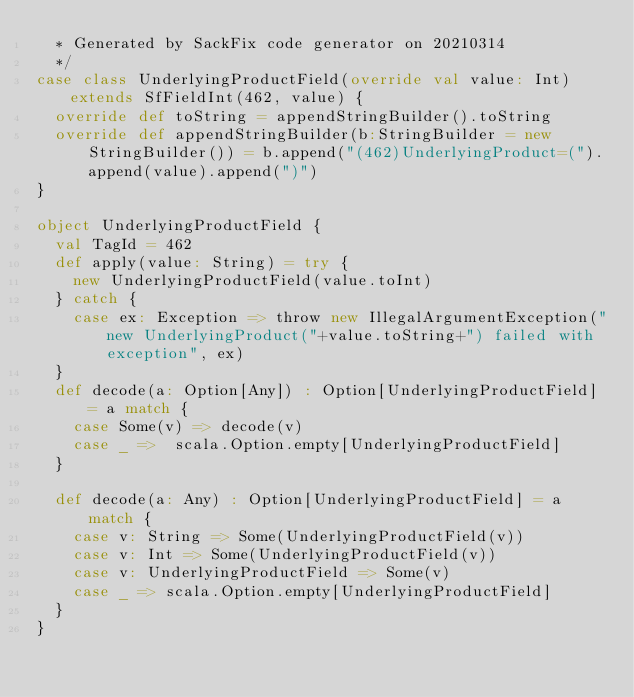<code> <loc_0><loc_0><loc_500><loc_500><_Scala_>  * Generated by SackFix code generator on 20210314
  */
case class UnderlyingProductField(override val value: Int) extends SfFieldInt(462, value) {
  override def toString = appendStringBuilder().toString
  override def appendStringBuilder(b:StringBuilder = new StringBuilder()) = b.append("(462)UnderlyingProduct=(").append(value).append(")")
}

object UnderlyingProductField {
  val TagId = 462  
  def apply(value: String) = try {
    new UnderlyingProductField(value.toInt)
  } catch {
    case ex: Exception => throw new IllegalArgumentException("new UnderlyingProduct("+value.toString+") failed with exception", ex)
  } 
  def decode(a: Option[Any]) : Option[UnderlyingProductField] = a match {
    case Some(v) => decode(v)
    case _ =>  scala.Option.empty[UnderlyingProductField]
  }

  def decode(a: Any) : Option[UnderlyingProductField] = a match {
    case v: String => Some(UnderlyingProductField(v))
    case v: Int => Some(UnderlyingProductField(v))
    case v: UnderlyingProductField => Some(v)
    case _ => scala.Option.empty[UnderlyingProductField]
  } 
}
</code> 